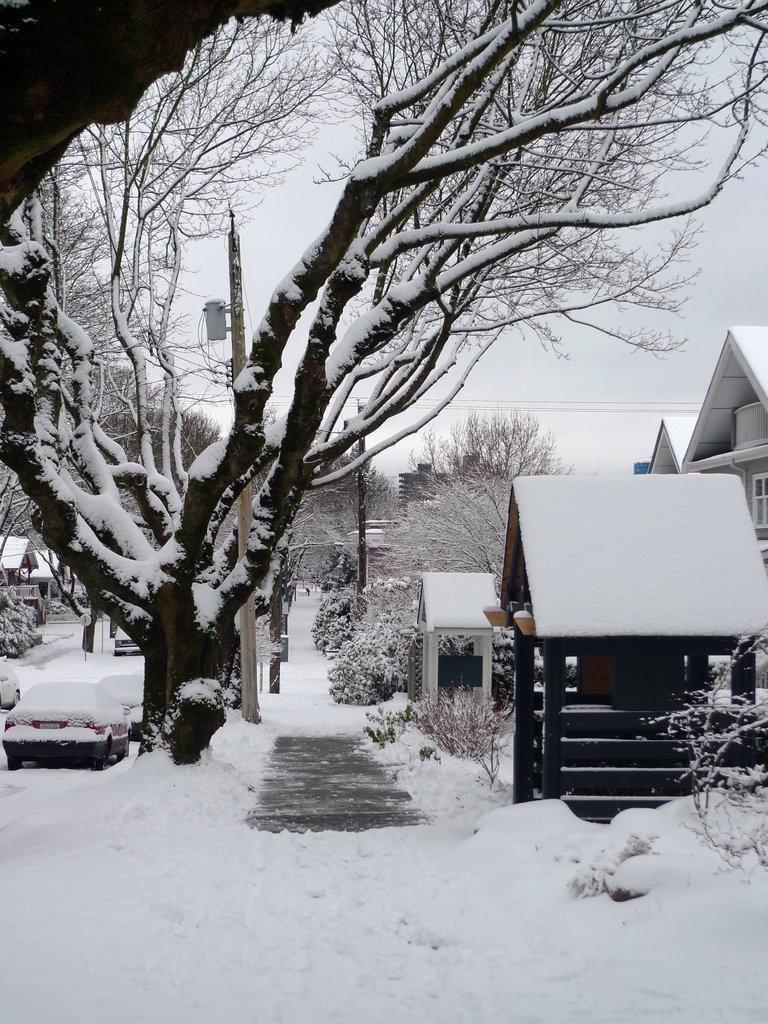Can you describe this image briefly? At the bottom of the picture, we see the road which is covered with the ice. On the right side, we see the trees and the buildings. On the left side, we see a red car which is covered with the ice. Beside that, we see a tree and the electric poles. There are trees and a building in the background. At the top, we see the sky and the wires. 